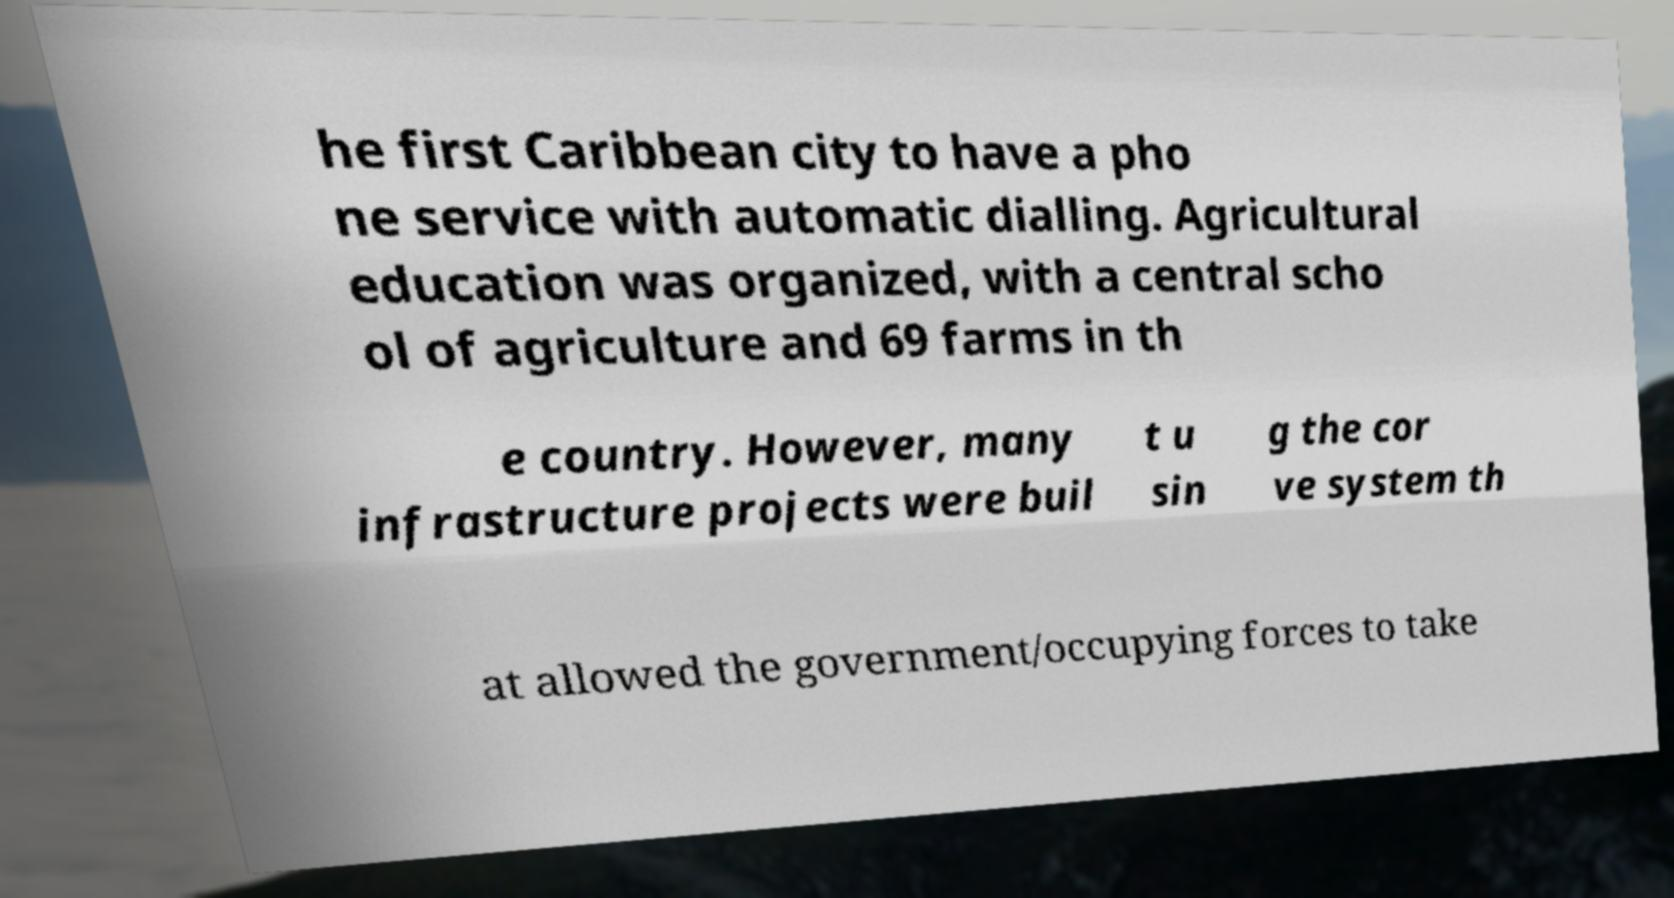Could you assist in decoding the text presented in this image and type it out clearly? he first Caribbean city to have a pho ne service with automatic dialling. Agricultural education was organized, with a central scho ol of agriculture and 69 farms in th e country. However, many infrastructure projects were buil t u sin g the cor ve system th at allowed the government/occupying forces to take 